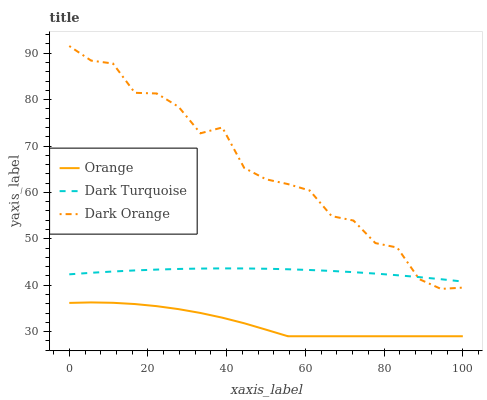Does Orange have the minimum area under the curve?
Answer yes or no. Yes. Does Dark Orange have the maximum area under the curve?
Answer yes or no. Yes. Does Dark Turquoise have the minimum area under the curve?
Answer yes or no. No. Does Dark Turquoise have the maximum area under the curve?
Answer yes or no. No. Is Dark Turquoise the smoothest?
Answer yes or no. Yes. Is Dark Orange the roughest?
Answer yes or no. Yes. Is Dark Orange the smoothest?
Answer yes or no. No. Is Dark Turquoise the roughest?
Answer yes or no. No. Does Dark Orange have the lowest value?
Answer yes or no. No. Does Dark Turquoise have the highest value?
Answer yes or no. No. Is Orange less than Dark Turquoise?
Answer yes or no. Yes. Is Dark Turquoise greater than Orange?
Answer yes or no. Yes. Does Orange intersect Dark Turquoise?
Answer yes or no. No. 